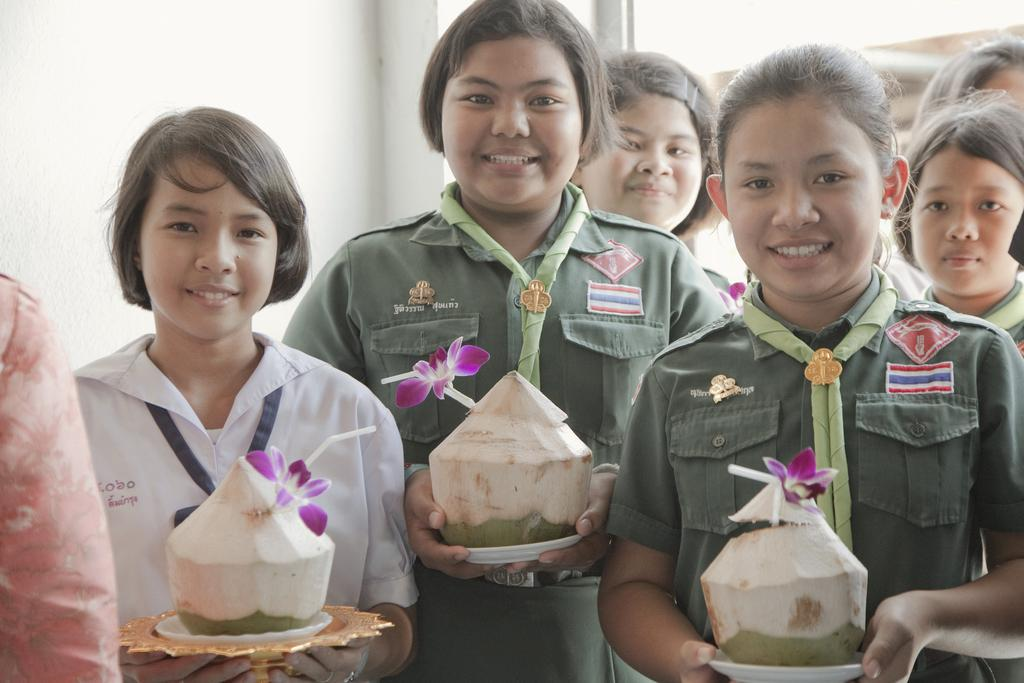Who is present in the image? There are girls in the image. What are the girls wearing? The girls are wearing scout uniforms. What are the girls holding in the image? The girls are holding coconuts with straw and a flower on them. What can be seen in the background of the image? There is a wall visible in the background of the image. What type of vase can be seen on the table in the image? There is no vase present in the image; the girls are holding coconuts with straw and a flower on them. How many clovers are visible on the ground in the image? There are no clovers visible in the image; the focus is on the girls and their coconuts. 